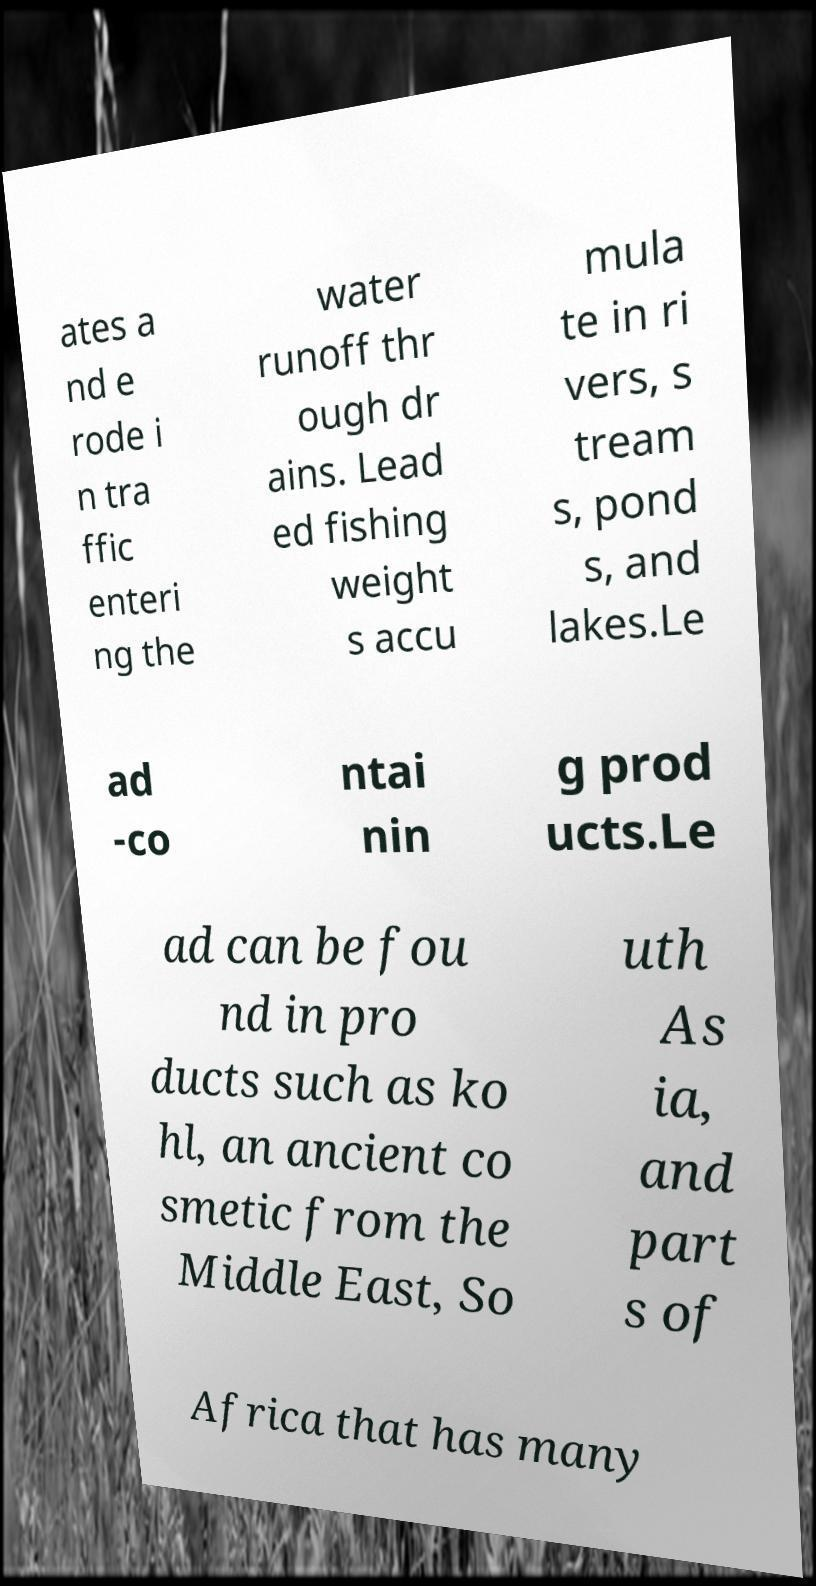Can you accurately transcribe the text from the provided image for me? ates a nd e rode i n tra ffic enteri ng the water runoff thr ough dr ains. Lead ed fishing weight s accu mula te in ri vers, s tream s, pond s, and lakes.Le ad -co ntai nin g prod ucts.Le ad can be fou nd in pro ducts such as ko hl, an ancient co smetic from the Middle East, So uth As ia, and part s of Africa that has many 